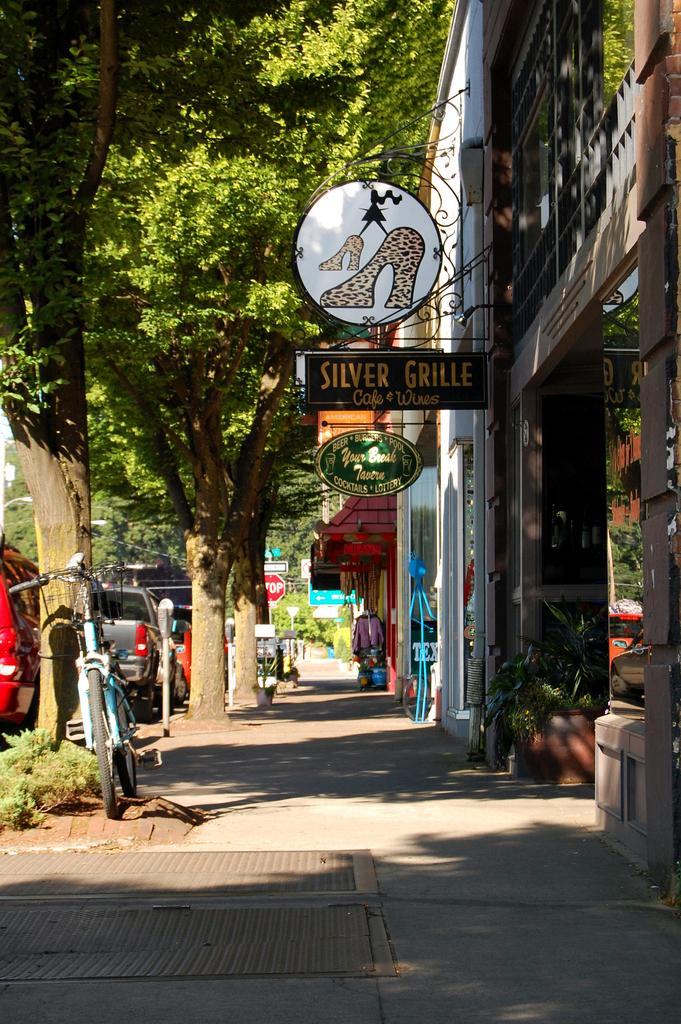What types of vehicles are in the image? There are motor vehicles in the image. What other mode of transportation can be seen in the image? There is a bicycle in the image. What natural elements are present in the image? Trees are present in the image. What type of establishments can be seen in the image? There are stores in the image. What signage is visible in the image? Sign boards and name boards are visible in the image. What decorative elements are present in the image? Houseplants are visible in the image. What facilities are present in the image for waste disposal? Trash bins are present in the image. What type of rings can be seen on the apparel of the people in the image? There are no people or apparel present in the image, so there are no rings to be seen. What type of powder is being used by the person in the image? There are no people or powder present in the image, so it cannot be determined what type of powder might be used. 